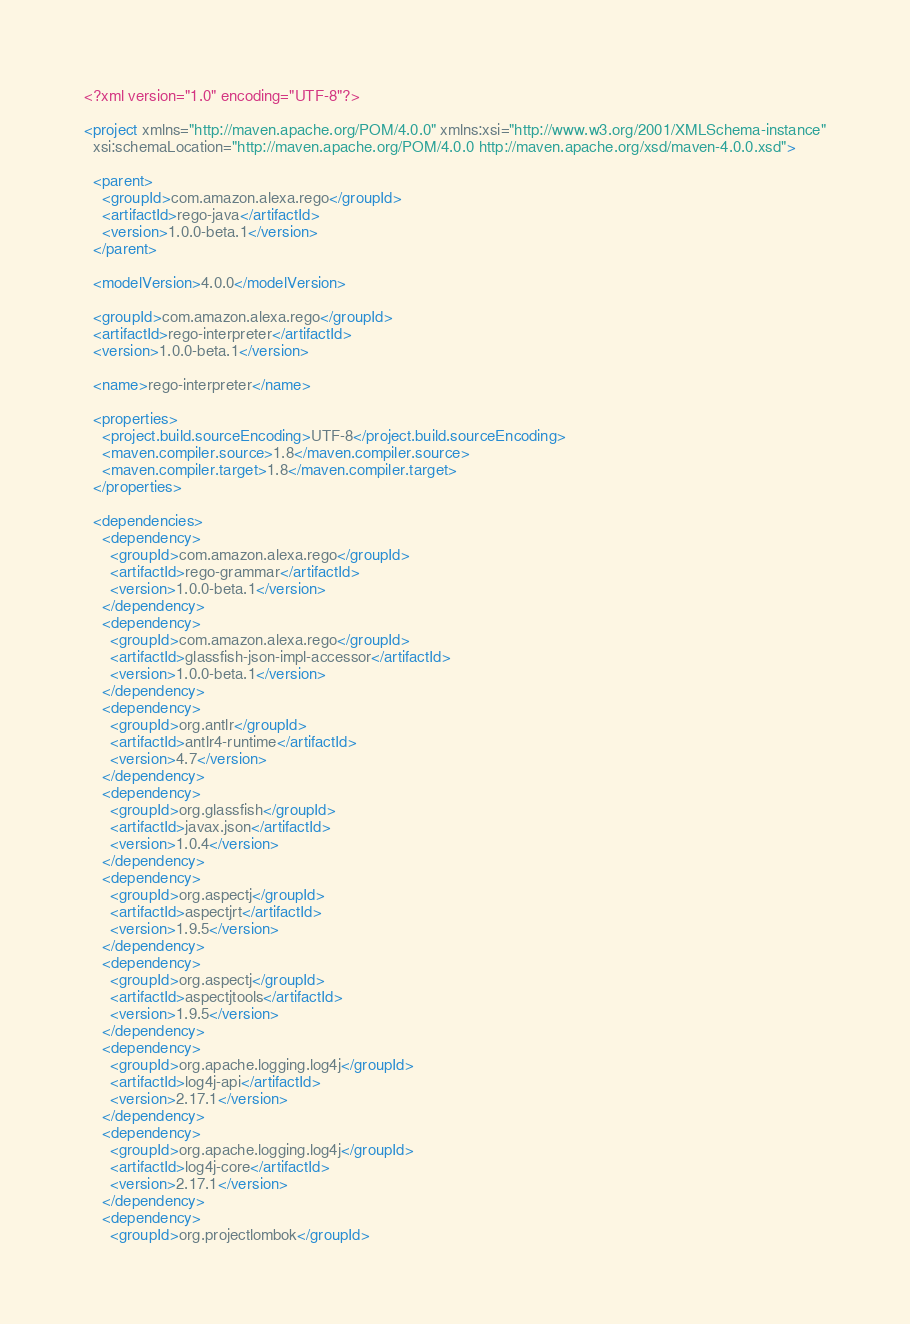<code> <loc_0><loc_0><loc_500><loc_500><_XML_><?xml version="1.0" encoding="UTF-8"?>

<project xmlns="http://maven.apache.org/POM/4.0.0" xmlns:xsi="http://www.w3.org/2001/XMLSchema-instance"
  xsi:schemaLocation="http://maven.apache.org/POM/4.0.0 http://maven.apache.org/xsd/maven-4.0.0.xsd">

  <parent>
    <groupId>com.amazon.alexa.rego</groupId>
    <artifactId>rego-java</artifactId>
    <version>1.0.0-beta.1</version>
  </parent>

  <modelVersion>4.0.0</modelVersion>

  <groupId>com.amazon.alexa.rego</groupId>
  <artifactId>rego-interpreter</artifactId>
  <version>1.0.0-beta.1</version>

  <name>rego-interpreter</name>

  <properties>
    <project.build.sourceEncoding>UTF-8</project.build.sourceEncoding>
    <maven.compiler.source>1.8</maven.compiler.source>
    <maven.compiler.target>1.8</maven.compiler.target>
  </properties>

  <dependencies>
    <dependency>
      <groupId>com.amazon.alexa.rego</groupId>
      <artifactId>rego-grammar</artifactId>
      <version>1.0.0-beta.1</version>
    </dependency>
    <dependency>
      <groupId>com.amazon.alexa.rego</groupId>
      <artifactId>glassfish-json-impl-accessor</artifactId>
      <version>1.0.0-beta.1</version>
    </dependency>
    <dependency>
      <groupId>org.antlr</groupId>
      <artifactId>antlr4-runtime</artifactId>
      <version>4.7</version>
    </dependency>
    <dependency>
      <groupId>org.glassfish</groupId>
      <artifactId>javax.json</artifactId>
      <version>1.0.4</version>
    </dependency>
    <dependency>
      <groupId>org.aspectj</groupId>
      <artifactId>aspectjrt</artifactId>
      <version>1.9.5</version>
    </dependency>
    <dependency>
      <groupId>org.aspectj</groupId>
      <artifactId>aspectjtools</artifactId>
      <version>1.9.5</version>
    </dependency>
    <dependency>
      <groupId>org.apache.logging.log4j</groupId>
      <artifactId>log4j-api</artifactId>
      <version>2.17.1</version>
    </dependency>
    <dependency>
      <groupId>org.apache.logging.log4j</groupId>
      <artifactId>log4j-core</artifactId>
      <version>2.17.1</version>
    </dependency>
    <dependency>
      <groupId>org.projectlombok</groupId></code> 